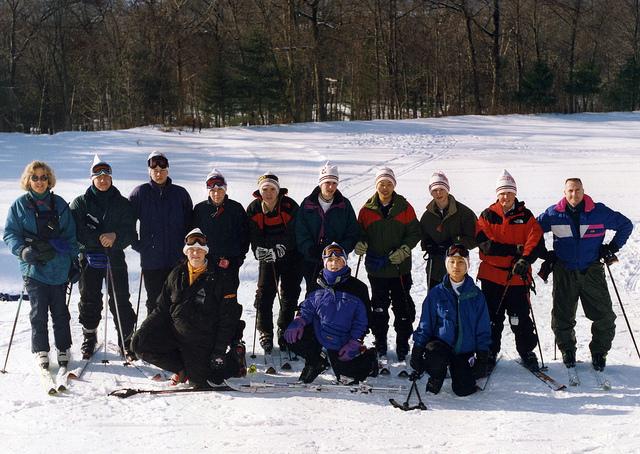How many people are wearing white hats?
Be succinct. 11. Is there snow on the ground?
Write a very short answer. Yes. What is in the background of the photo?
Answer briefly. Trees. 